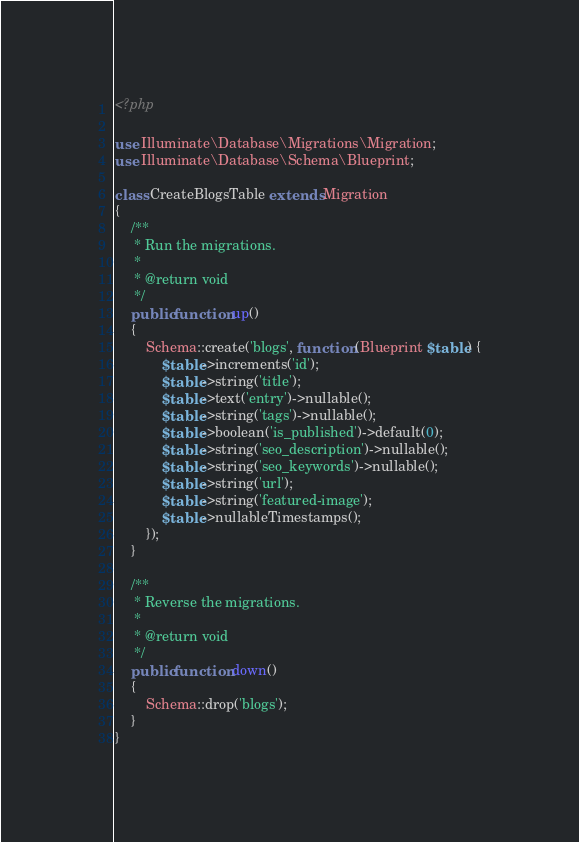<code> <loc_0><loc_0><loc_500><loc_500><_PHP_><?php

use Illuminate\Database\Migrations\Migration;
use Illuminate\Database\Schema\Blueprint;

class CreateBlogsTable extends Migration
{
    /**
     * Run the migrations.
     *
     * @return void
     */
    public function up()
    {
        Schema::create('blogs', function (Blueprint $table) {
            $table->increments('id');
            $table->string('title');
            $table->text('entry')->nullable();
            $table->string('tags')->nullable();
            $table->boolean('is_published')->default(0);
            $table->string('seo_description')->nullable();
            $table->string('seo_keywords')->nullable();
            $table->string('url');
            $table->string('featured-image');
            $table->nullableTimestamps();
        });
    }

    /**
     * Reverse the migrations.
     *
     * @return void
     */
    public function down()
    {
        Schema::drop('blogs');
    }
}
</code> 